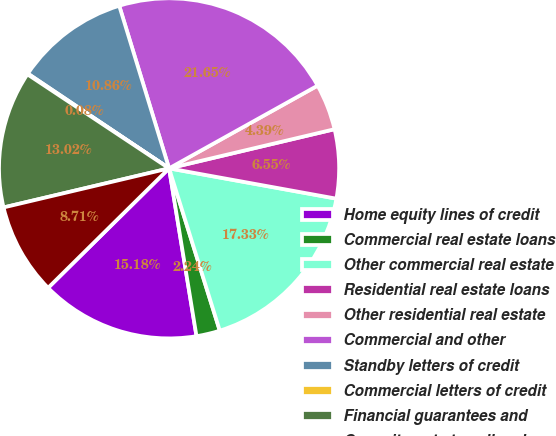Convert chart to OTSL. <chart><loc_0><loc_0><loc_500><loc_500><pie_chart><fcel>Home equity lines of credit<fcel>Commercial real estate loans<fcel>Other commercial real estate<fcel>Residential real estate loans<fcel>Other residential real estate<fcel>Commercial and other<fcel>Standby letters of credit<fcel>Commercial letters of credit<fcel>Financial guarantees and<fcel>Commitments to sell real<nl><fcel>15.18%<fcel>2.24%<fcel>17.33%<fcel>6.55%<fcel>4.39%<fcel>21.65%<fcel>10.86%<fcel>0.08%<fcel>13.02%<fcel>8.71%<nl></chart> 